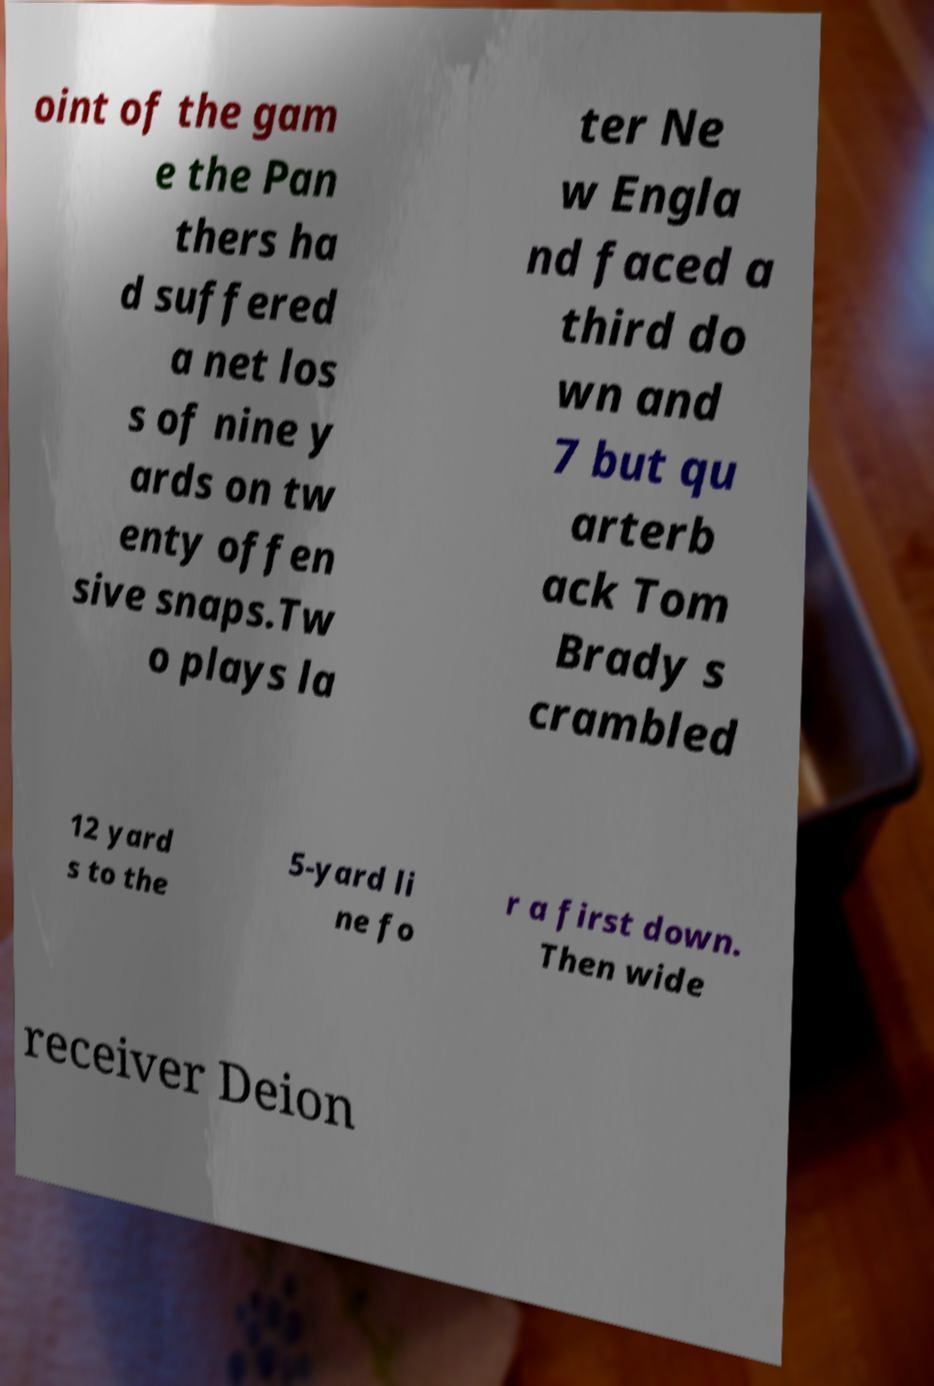I need the written content from this picture converted into text. Can you do that? oint of the gam e the Pan thers ha d suffered a net los s of nine y ards on tw enty offen sive snaps.Tw o plays la ter Ne w Engla nd faced a third do wn and 7 but qu arterb ack Tom Brady s crambled 12 yard s to the 5-yard li ne fo r a first down. Then wide receiver Deion 